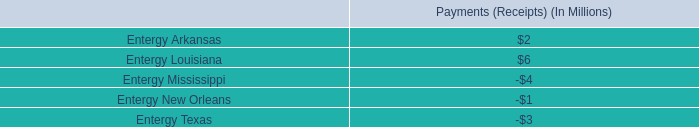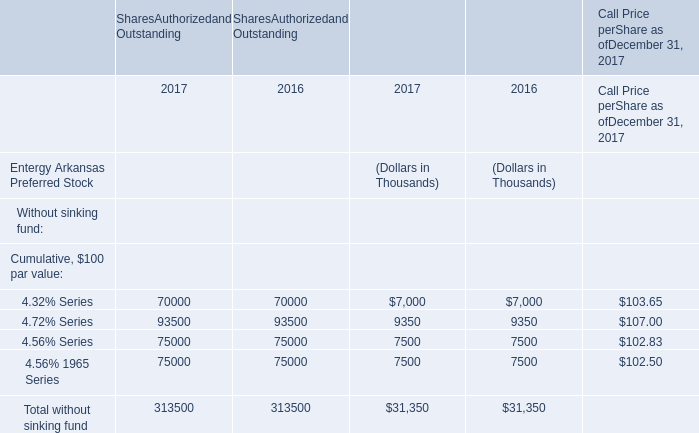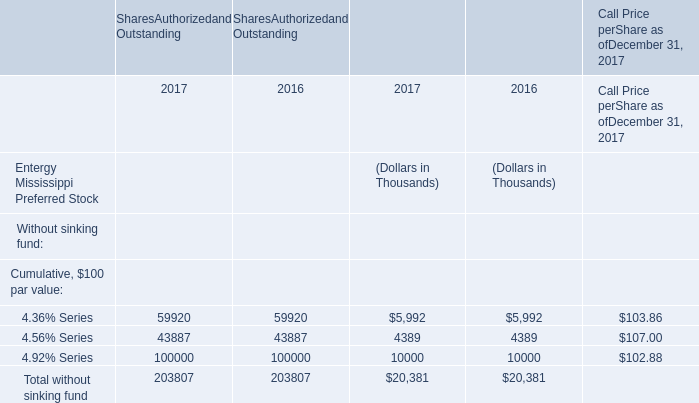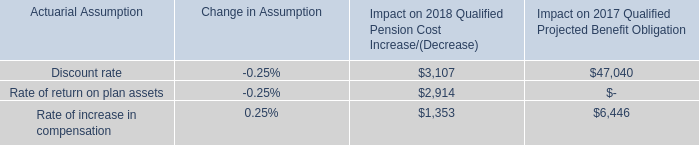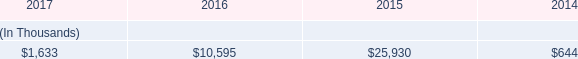not including letters from the uncommitted facility , what percent of the borrowings allowance do the letters of credits set to expire may 2018 amount to? 
Computations: (102.5 / 175)
Answer: 0.58571. 